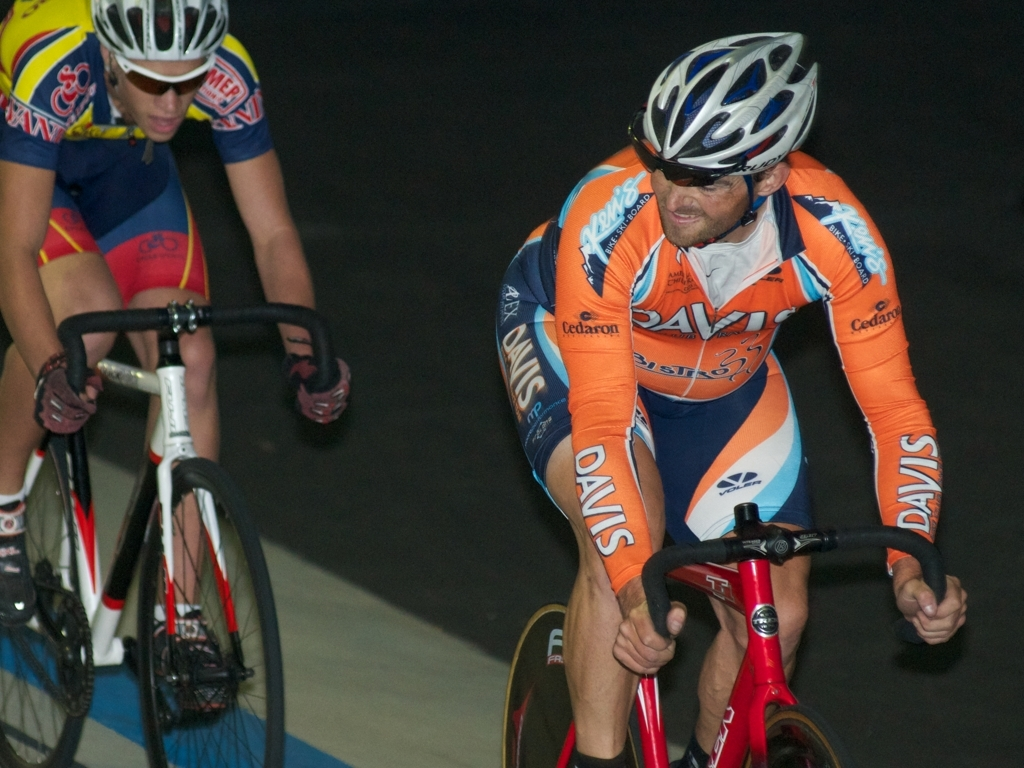What details stand out to you in their equipment? Their equipment is optimized for aerodynamics and speed. The slick, form-fitting uniforms reduce air resistance, and the helmets are streamlined for the same purpose. The bikes have minimalistic frames, and the spoke-less wheels are specially designed for track racing, all contributing to the high-performance nature of the sport. Is there anything in this image that speaks to the sport's culture or community? The teamwork and competition evident in the image portrays a slice of the sport's culture. The matching team kits suggest a sense of unity and identity within the teams, while the presence of competitors on the same track conveys the community's competitive spirit and the camaraderie that arises from a shared passion for the sport. 